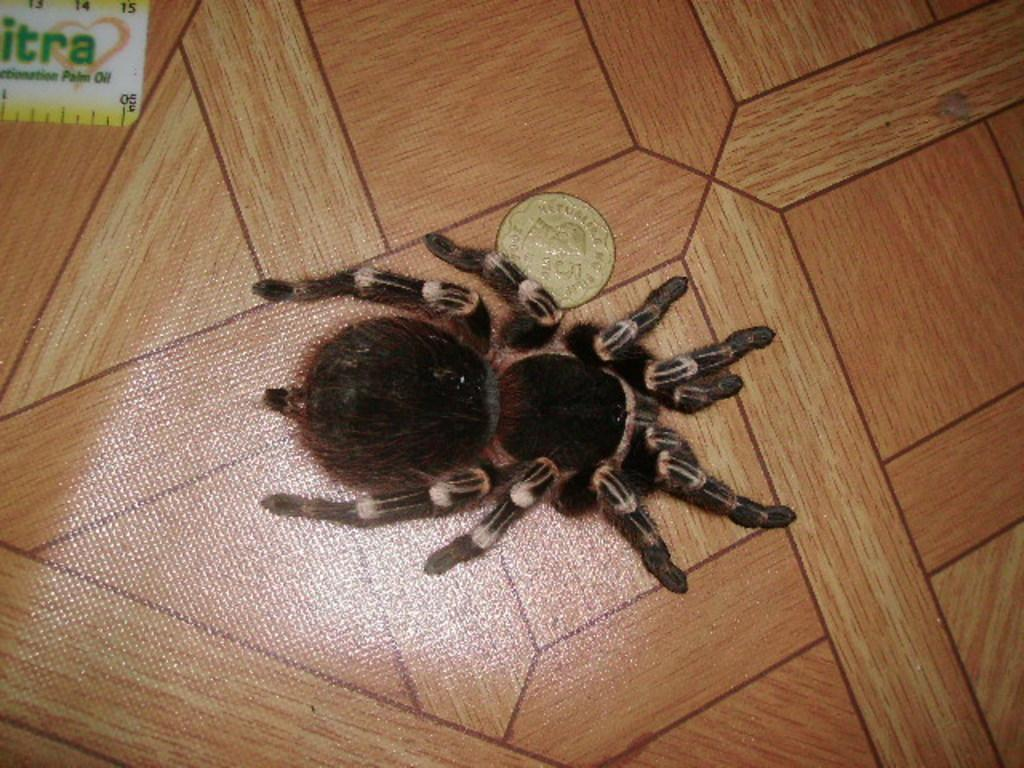What is the main subject of the image? There is a spider in the image. What other object can be seen in the image? There is a coin in the image. Where was the image taken? The image was taken in a house. What type of food is being prepared in the image? There is no food visible in the image; it features a spider and a coin. What is the profit margin of the business in the image? There is no business or profit margin mentioned in the image; it only shows a spider and a coin. 